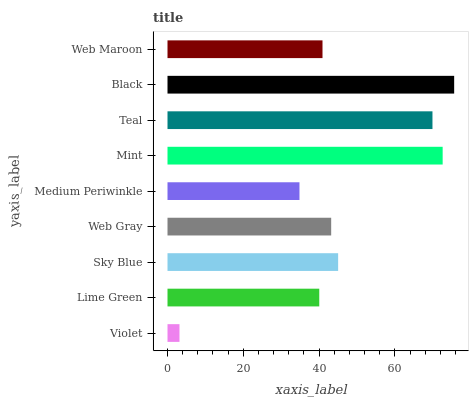Is Violet the minimum?
Answer yes or no. Yes. Is Black the maximum?
Answer yes or no. Yes. Is Lime Green the minimum?
Answer yes or no. No. Is Lime Green the maximum?
Answer yes or no. No. Is Lime Green greater than Violet?
Answer yes or no. Yes. Is Violet less than Lime Green?
Answer yes or no. Yes. Is Violet greater than Lime Green?
Answer yes or no. No. Is Lime Green less than Violet?
Answer yes or no. No. Is Web Gray the high median?
Answer yes or no. Yes. Is Web Gray the low median?
Answer yes or no. Yes. Is Lime Green the high median?
Answer yes or no. No. Is Sky Blue the low median?
Answer yes or no. No. 